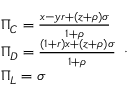<formula> <loc_0><loc_0><loc_500><loc_500>\begin{array} { l } { \Pi _ { C } = \frac { x - y r + ( z + \rho ) \sigma } { 1 + \rho } } \\ { \Pi _ { D } = \frac { ( 1 + r ) x + ( z + \rho ) \sigma } { 1 + \rho } } \\ { \Pi _ { L } = \sigma } \end{array} .</formula> 